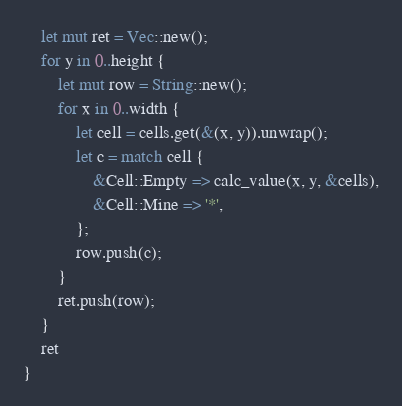Convert code to text. <code><loc_0><loc_0><loc_500><loc_500><_Rust_>
    let mut ret = Vec::new();
    for y in 0..height {
        let mut row = String::new();
        for x in 0..width {
            let cell = cells.get(&(x, y)).unwrap();
            let c = match cell {
                &Cell::Empty => calc_value(x, y, &cells),
                &Cell::Mine => '*',
            };
            row.push(c);
        }
        ret.push(row);
    }
    ret
}
</code> 